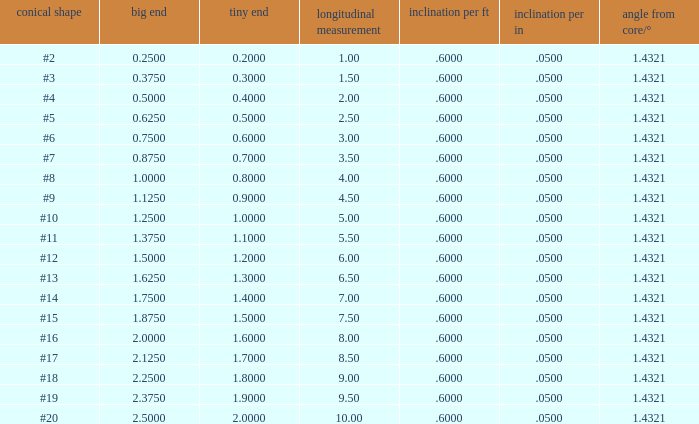Which Taper/ft that has a Large end smaller than 0.5, and a Taper of #2? 0.6. 